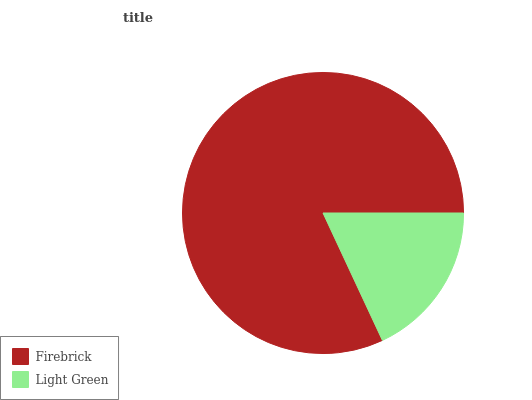Is Light Green the minimum?
Answer yes or no. Yes. Is Firebrick the maximum?
Answer yes or no. Yes. Is Light Green the maximum?
Answer yes or no. No. Is Firebrick greater than Light Green?
Answer yes or no. Yes. Is Light Green less than Firebrick?
Answer yes or no. Yes. Is Light Green greater than Firebrick?
Answer yes or no. No. Is Firebrick less than Light Green?
Answer yes or no. No. Is Firebrick the high median?
Answer yes or no. Yes. Is Light Green the low median?
Answer yes or no. Yes. Is Light Green the high median?
Answer yes or no. No. Is Firebrick the low median?
Answer yes or no. No. 